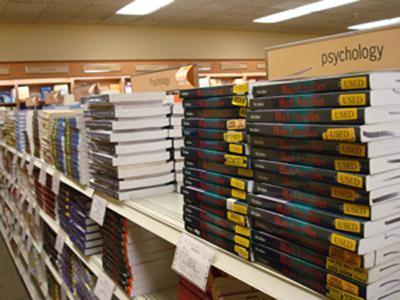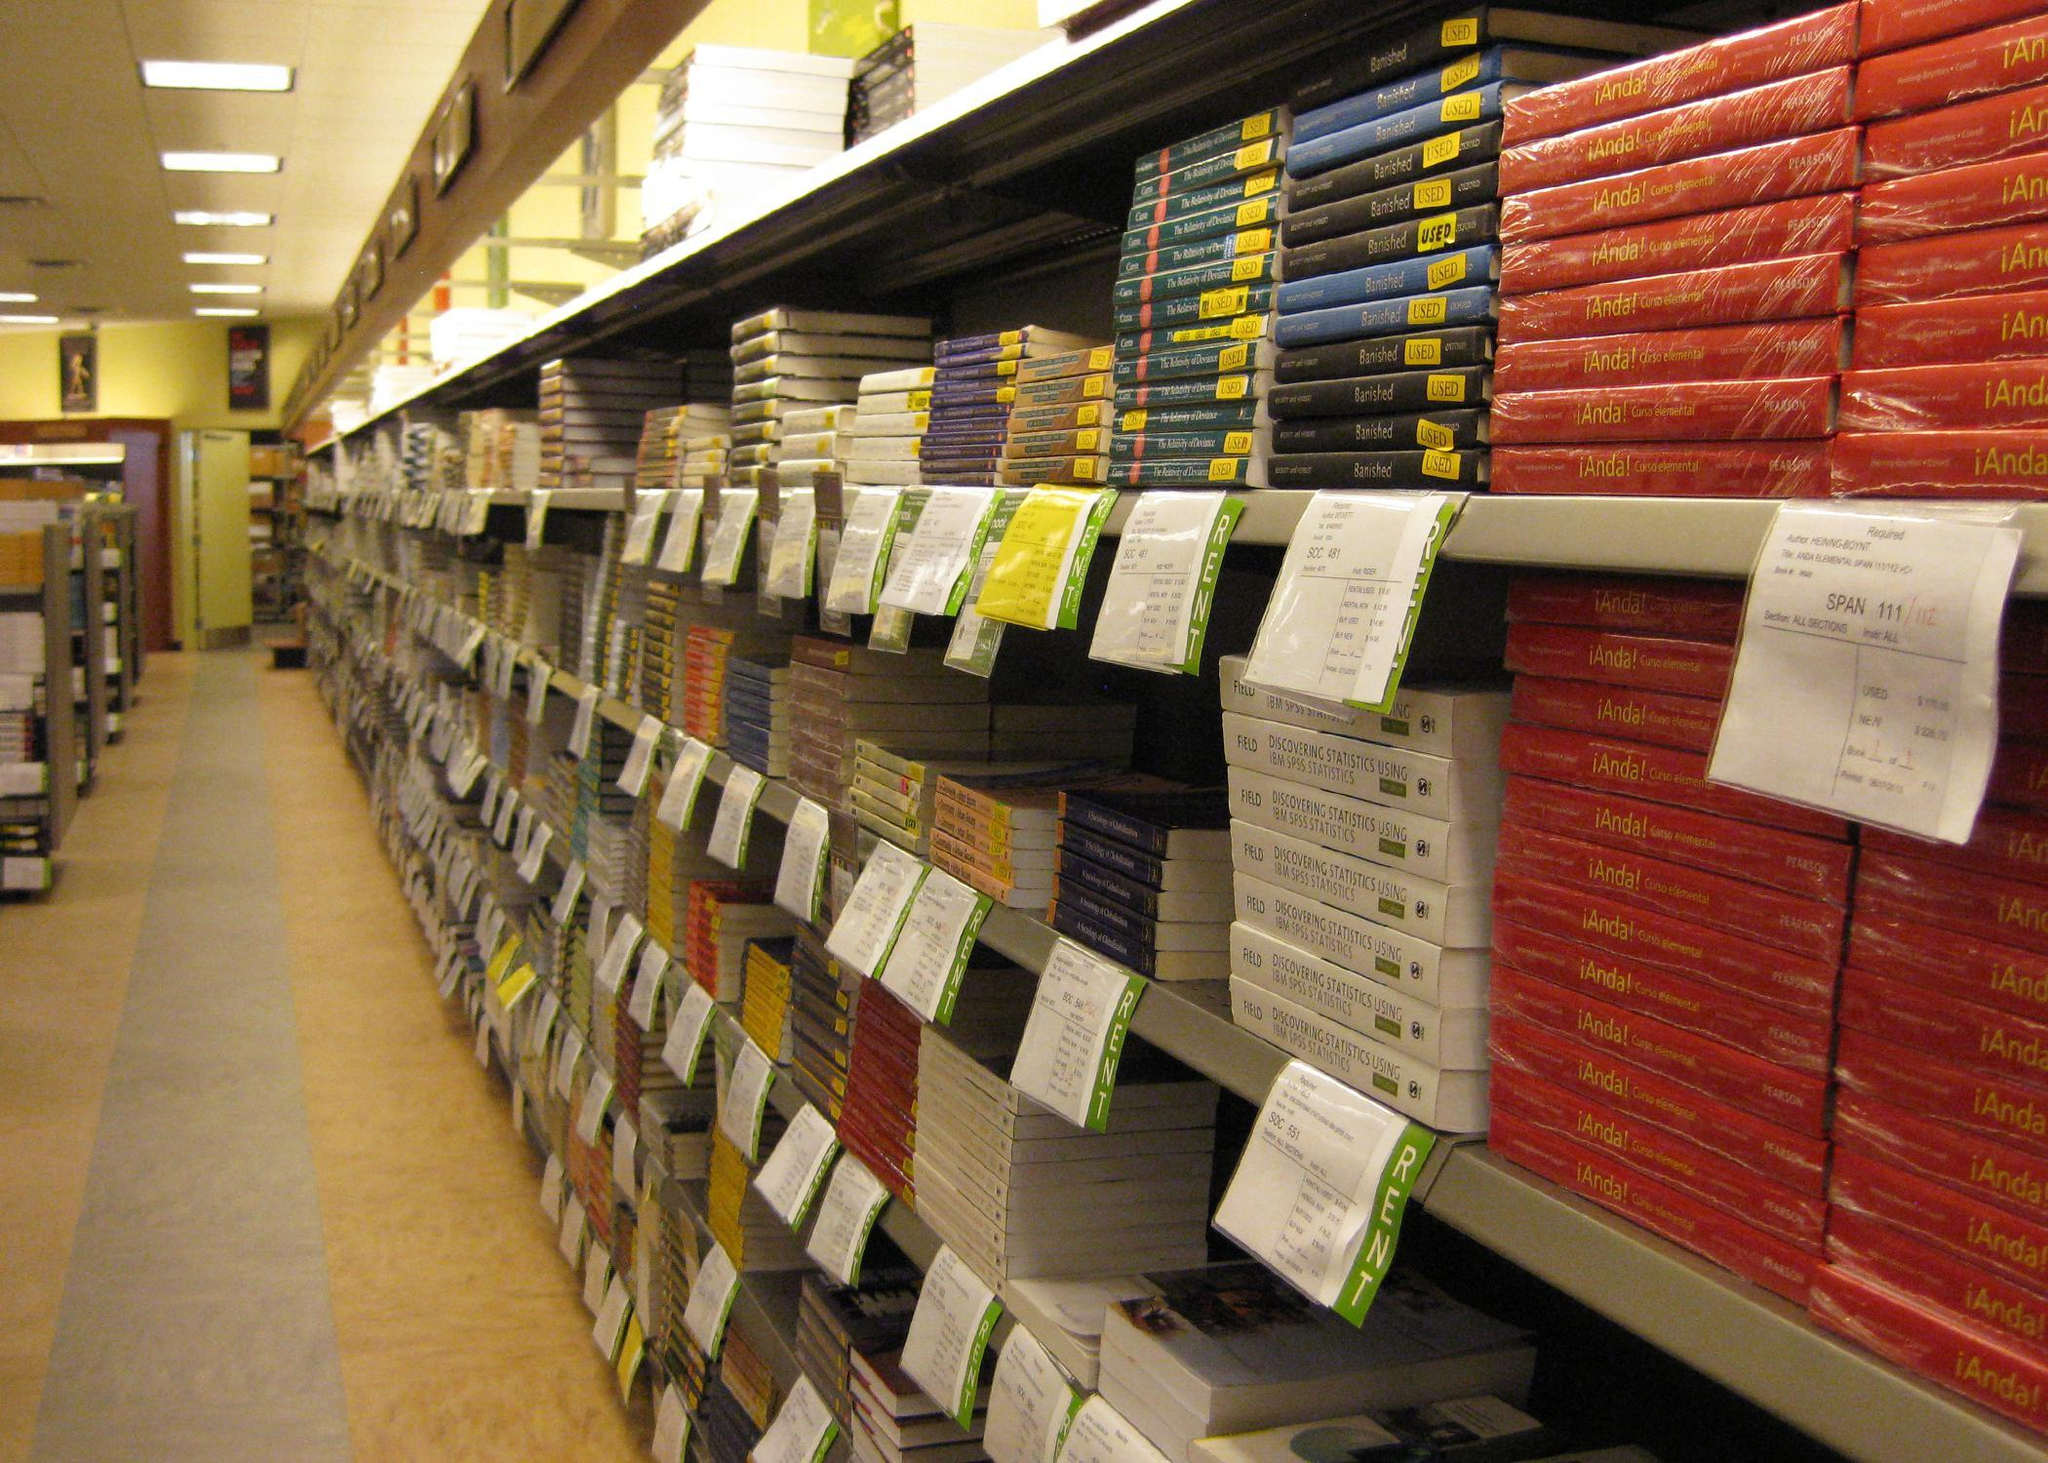The first image is the image on the left, the second image is the image on the right. Given the left and right images, does the statement "Several of the books on the shelves have yellow stickers." hold true? Answer yes or no. Yes. The first image is the image on the left, the second image is the image on the right. For the images displayed, is the sentence "In at least one image, books are stacked on their sides on shelves, some with yellow rectangles on their spines." factually correct? Answer yes or no. Yes. 